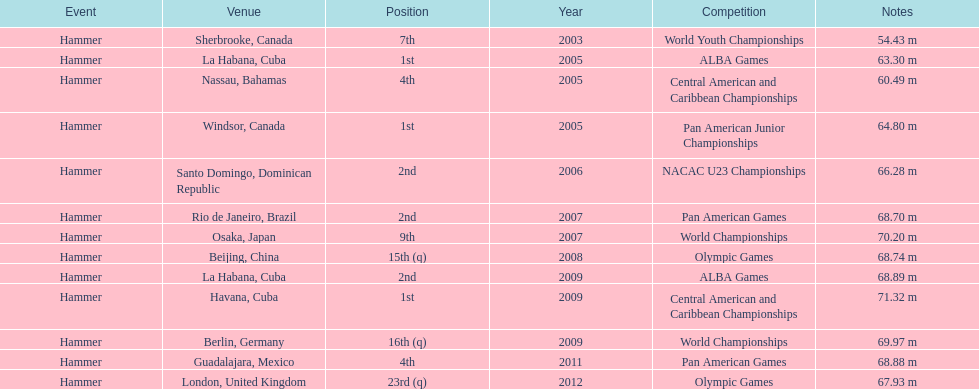In which olympic games did arasay thondike not finish in the top 20? 2012. 